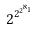<formula> <loc_0><loc_0><loc_500><loc_500>2 ^ { 2 ^ { 2 ^ { \aleph _ { 1 } } } }</formula> 